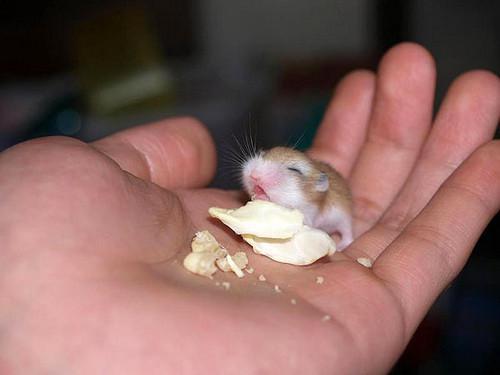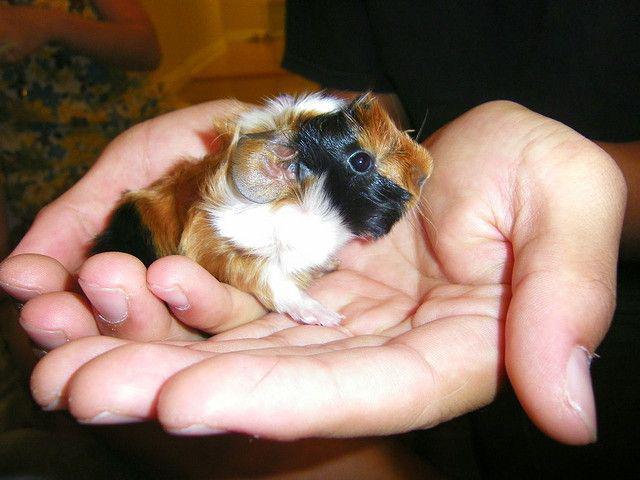The first image is the image on the left, the second image is the image on the right. Analyze the images presented: Is the assertion "In one of the images there is a pair of cupped hands holding a baby guinea pig." valid? Answer yes or no. Yes. The first image is the image on the left, the second image is the image on the right. Examine the images to the left and right. Is the description "Left image shows a pair of hands holding a tri-colored hamster." accurate? Answer yes or no. No. 